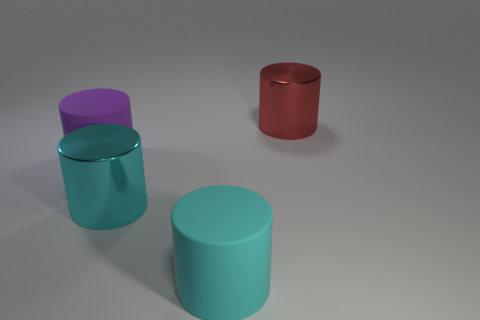Are there more purple cylinders behind the large cyan metal cylinder than big cyan metallic cylinders?
Keep it short and to the point. No. Is there a large purple object that has the same shape as the big cyan shiny thing?
Make the answer very short. Yes. Do the big red cylinder and the cyan object in front of the big cyan metallic cylinder have the same material?
Offer a very short reply. No. There is a large thing in front of the large metal cylinder that is in front of the large red object; what number of large matte things are left of it?
Your answer should be very brief. 1. Are there any red metal things to the right of the cyan rubber thing?
Provide a short and direct response. Yes. What number of things have the same material as the purple cylinder?
Offer a very short reply. 1. How many objects are either large cyan rubber cylinders or big cyan things?
Give a very brief answer. 2. Is there a large gray shiny thing?
Make the answer very short. No. What material is the purple object that is to the left of the big cyan matte cylinder right of the big cyan shiny cylinder that is right of the large purple matte object?
Offer a terse response. Rubber. Are there fewer big red cylinders that are behind the large cyan rubber object than matte cylinders?
Your response must be concise. Yes. 